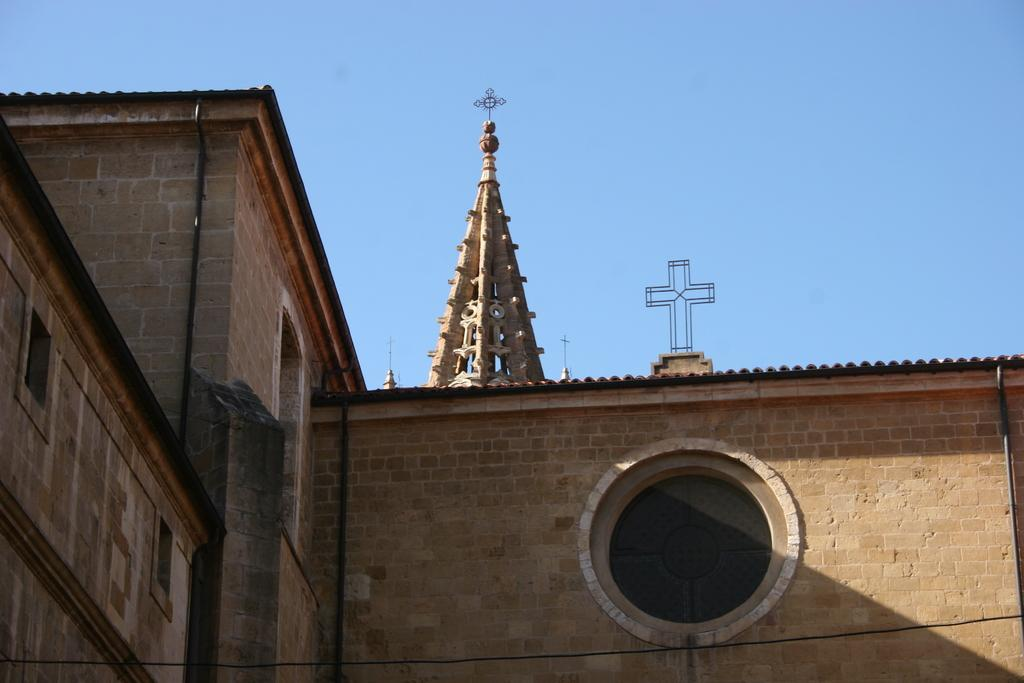What type of structure is visible in the image? There is a stone wall in the image. What symbol can be seen in the image? There is a cross symbol in the image. What part of the natural environment is visible in the image? The sky is visible in the image. What emotion does the stone wall express in the image? Stone walls do not express emotions; they are inanimate objects. 